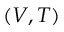Convert formula to latex. <formula><loc_0><loc_0><loc_500><loc_500>( V , T )</formula> 